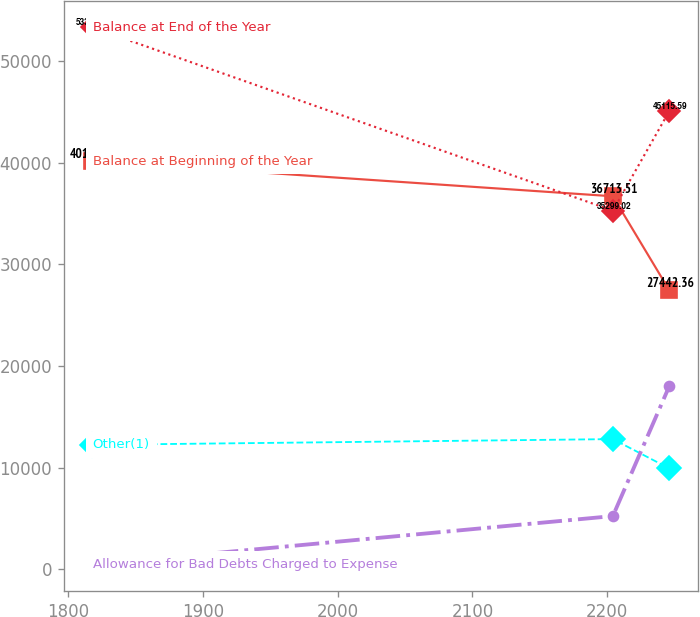<chart> <loc_0><loc_0><loc_500><loc_500><line_chart><ecel><fcel>Balance at Beginning of the Year<fcel>Balance at End of the Year<fcel>Other(1)<fcel>Allowance for Bad Debts Charged to Expense<nl><fcel>1818.07<fcel>40176.5<fcel>53323.3<fcel>12250<fcel>477.31<nl><fcel>2204.22<fcel>36713.5<fcel>35299<fcel>12816.4<fcel>5239.69<nl><fcel>2246.19<fcel>27442.4<fcel>45115.6<fcel>9926.04<fcel>18054.7<nl></chart> 